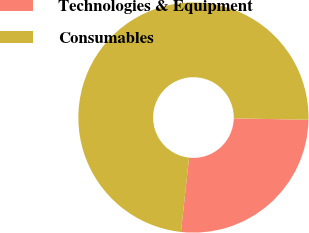<chart> <loc_0><loc_0><loc_500><loc_500><pie_chart><fcel>Technologies & Equipment<fcel>Consumables<nl><fcel>26.42%<fcel>73.58%<nl></chart> 